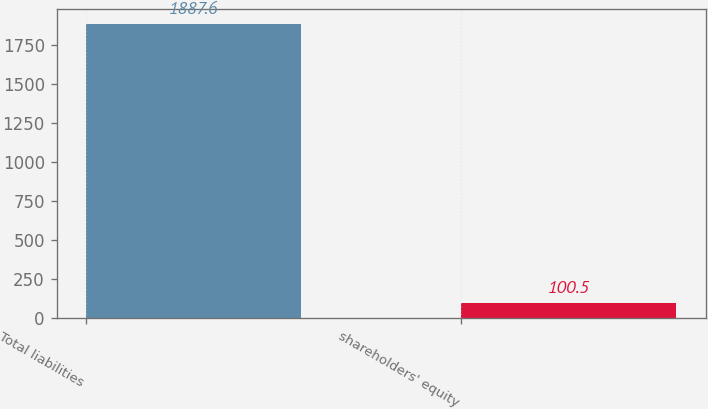Convert chart. <chart><loc_0><loc_0><loc_500><loc_500><bar_chart><fcel>Total liabilities<fcel>shareholders' equity<nl><fcel>1887.6<fcel>100.5<nl></chart> 